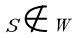<formula> <loc_0><loc_0><loc_500><loc_500>S \notin W</formula> 